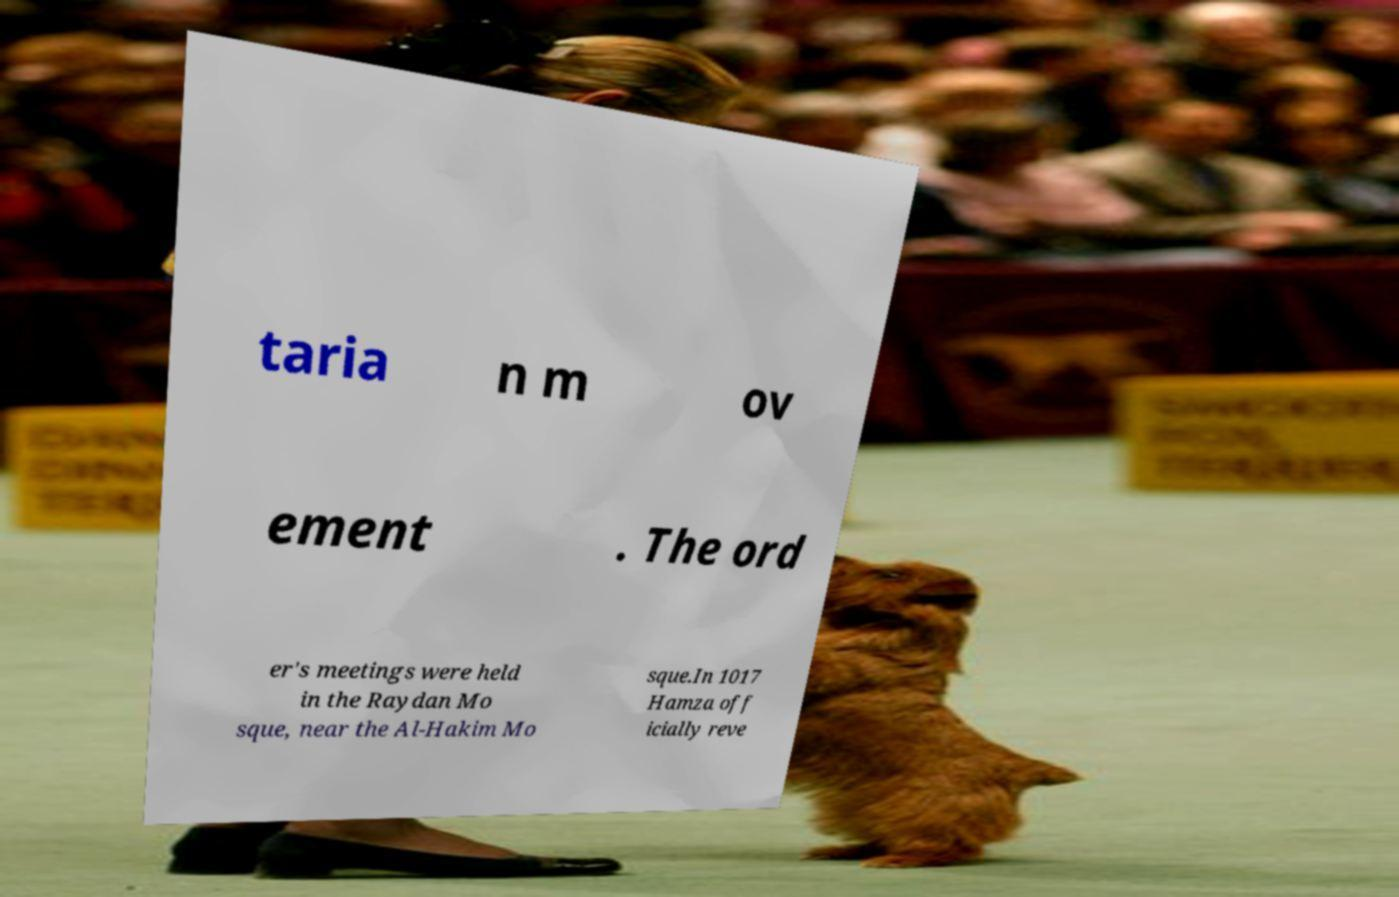Can you read and provide the text displayed in the image?This photo seems to have some interesting text. Can you extract and type it out for me? taria n m ov ement . The ord er's meetings were held in the Raydan Mo sque, near the Al-Hakim Mo sque.In 1017 Hamza off icially reve 